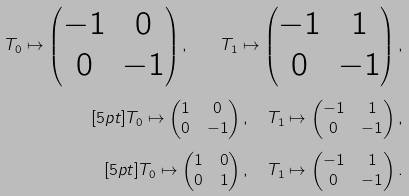<formula> <loc_0><loc_0><loc_500><loc_500>T _ { 0 } \mapsto \begin{pmatrix} - 1 & 0 \\ 0 & - 1 \end{pmatrix} , \quad T _ { 1 } \mapsto \begin{pmatrix} - 1 & 1 \\ 0 & - 1 \end{pmatrix} , \\ [ 5 p t ] T _ { 0 } \mapsto \begin{pmatrix} 1 & 0 \\ 0 & - 1 \end{pmatrix} , \quad T _ { 1 } \mapsto \begin{pmatrix} - 1 & 1 \\ 0 & - 1 \end{pmatrix} , \\ [ 5 p t ] T _ { 0 } \mapsto \begin{pmatrix} 1 & 0 \\ 0 & 1 \end{pmatrix} , \quad T _ { 1 } \mapsto \begin{pmatrix} - 1 & 1 \\ 0 & - 1 \end{pmatrix} .</formula> 